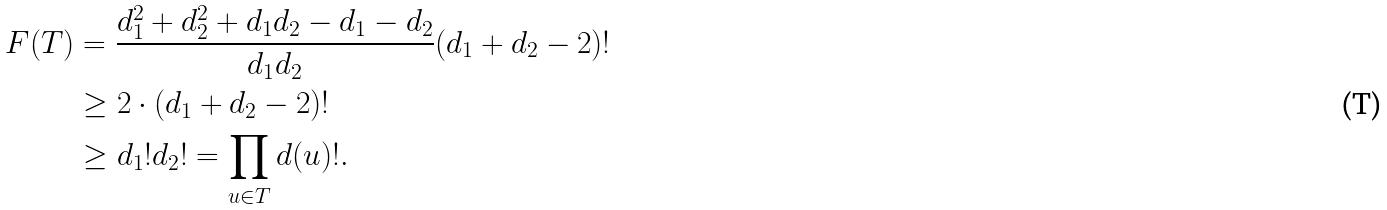<formula> <loc_0><loc_0><loc_500><loc_500>F ( T ) & = \frac { d _ { 1 } ^ { 2 } + d _ { 2 } ^ { 2 } + d _ { 1 } d _ { 2 } - d _ { 1 } - d _ { 2 } } { d _ { 1 } d _ { 2 } } ( d _ { 1 } + d _ { 2 } - 2 ) ! \\ & \geq 2 \cdot ( d _ { 1 } + d _ { 2 } - 2 ) ! \\ & \geq d _ { 1 } ! d _ { 2 } ! = \prod _ { u \in T } d ( u ) ! .</formula> 